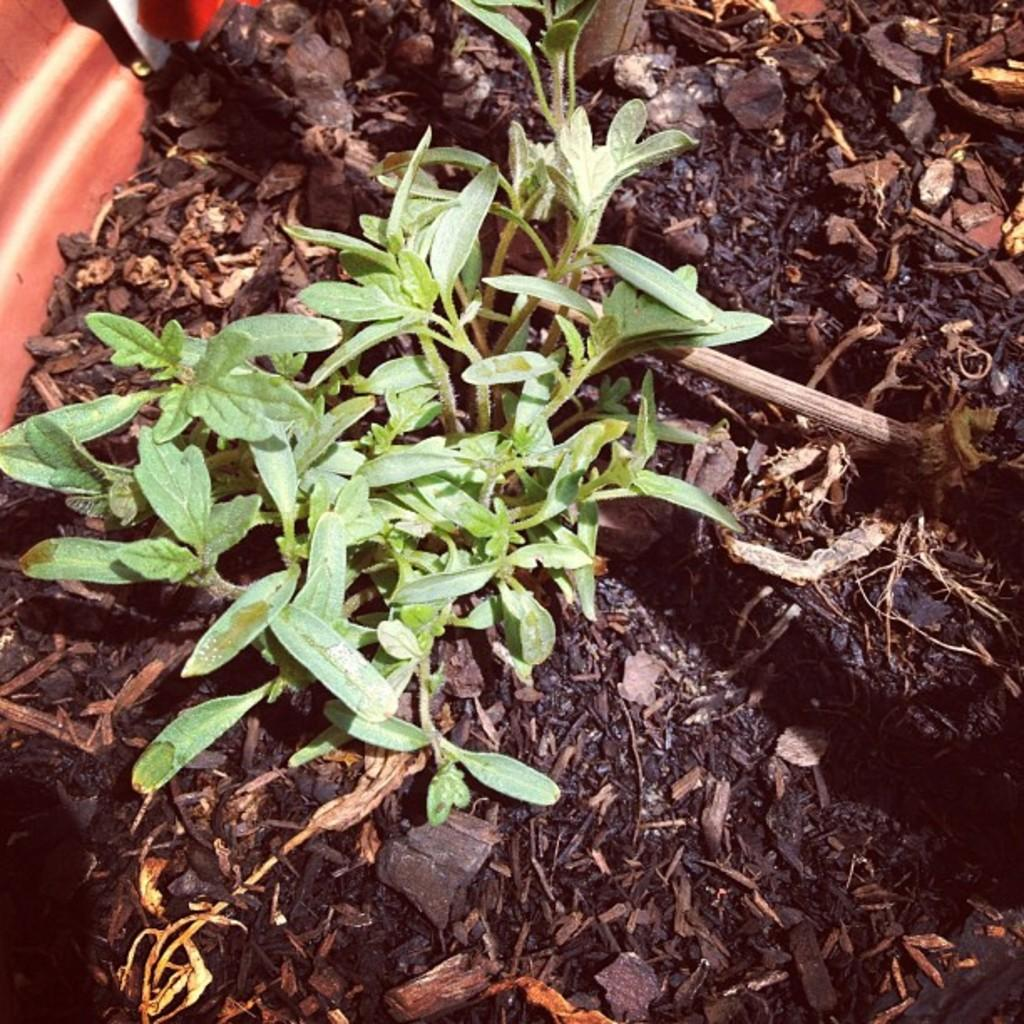What type of plants can be seen in the image? There are small green plants in the image. What else can be seen on the ground in the image? There are dry leaves on a path in the image. How many hands are holding the peace sign in the image? There are no hands or peace signs present in the image; it only features small green plants and dry leaves on a path. 